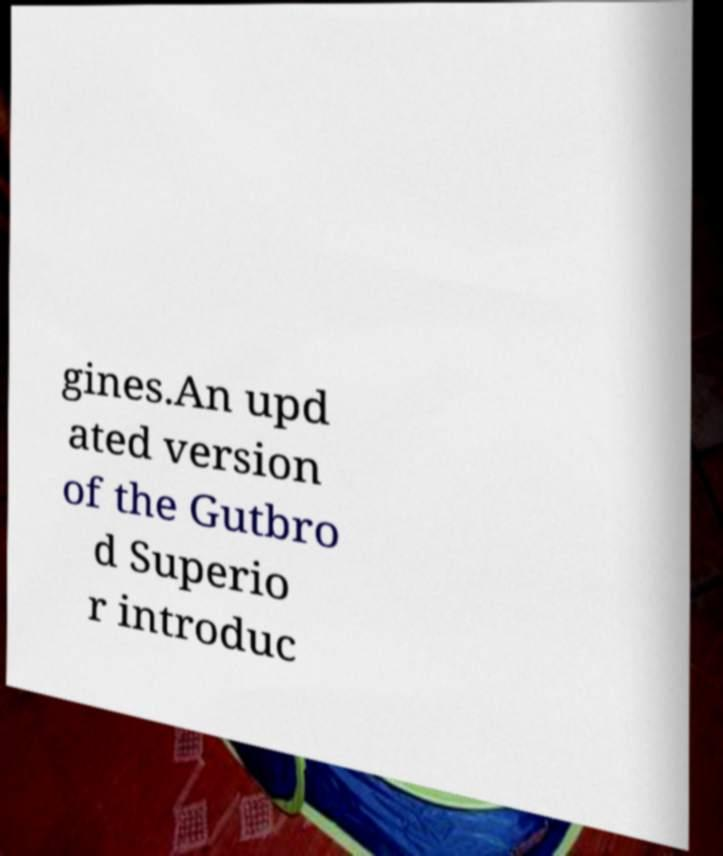Please read and relay the text visible in this image. What does it say? gines.An upd ated version of the Gutbro d Superio r introduc 